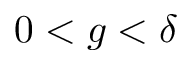<formula> <loc_0><loc_0><loc_500><loc_500>0 < g < \delta</formula> 